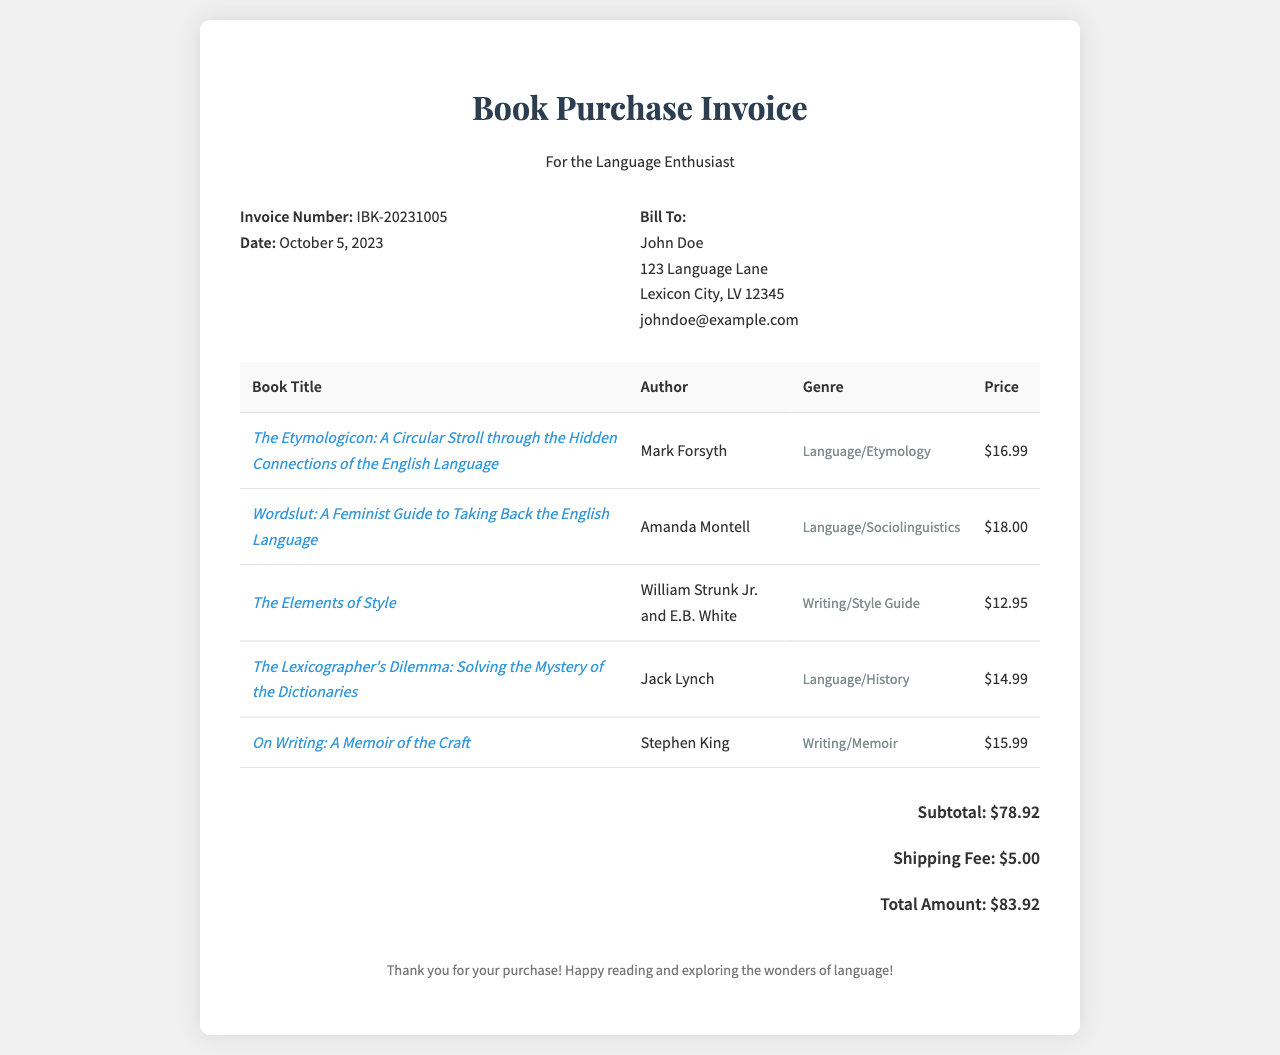What is the invoice number? The invoice number is clearly stated in the document, which is unique to this transaction.
Answer: IBK-20231005 Who is the author of "Wordslut: A Feminist Guide to Taking Back the English Language"? The author's name is listed alongside the book title in the table.
Answer: Amanda Montell What is the genre of "The Elements of Style"? The genre is provided in the table next to the book title.
Answer: Writing/Style Guide What is the subtotal of the invoice? The subtotal is shown prominently in the document as part of the total calculation.
Answer: $78.92 What is the total amount due? The total amount is the final figure displayed after adding up the subtotal and shipping fee.
Answer: $83.92 How many books are listed in the invoice? The number of books can be counted from the rows in the book table.
Answer: 5 What is the shipping fee? The shipping fee is specified separately in the invoice totals.
Answer: $5.00 What date was the invoice issued? The date of the invoice is explicitly mentioned among the invoice details.
Answer: October 5, 2023 What message is included in the footer? The footer contains a closing message thanking the customer for their purchase.
Answer: Thank you for your purchase! Happy reading and exploring the wonders of language! 